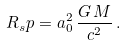Convert formula to latex. <formula><loc_0><loc_0><loc_500><loc_500>R _ { s } p = { a _ { 0 } ^ { 2 } } \, \frac { G \, M } { c ^ { 2 } } \, .</formula> 